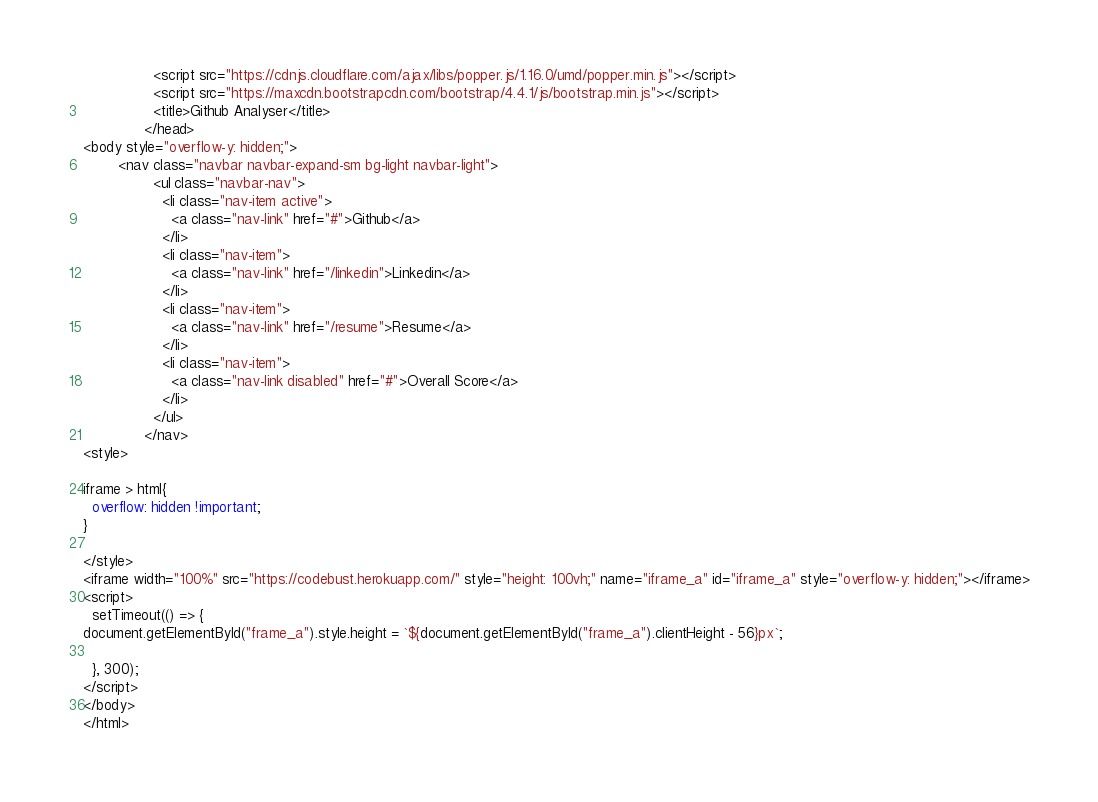Convert code to text. <code><loc_0><loc_0><loc_500><loc_500><_HTML_>                <script src="https://cdnjs.cloudflare.com/ajax/libs/popper.js/1.16.0/umd/popper.min.js"></script>
                <script src="https://maxcdn.bootstrapcdn.com/bootstrap/4.4.1/js/bootstrap.min.js"></script>
                <title>Github Analyser</title>
              </head>
<body style="overflow-y: hidden;">
        <nav class="navbar navbar-expand-sm bg-light navbar-light">
                <ul class="navbar-nav">
                  <li class="nav-item active">
                    <a class="nav-link" href="#">Github</a>
                  </li>
                  <li class="nav-item">
                    <a class="nav-link" href="/linkedin">Linkedin</a>
                  </li>
                  <li class="nav-item">
                    <a class="nav-link" href="/resume">Resume</a>
                  </li>
                  <li class="nav-item">
                    <a class="nav-link disabled" href="#">Overall Score</a>
                  </li>
                </ul>
              </nav>
<style>

iframe > html{
  overflow: hidden !important;
}

</style>
<iframe width="100%" src="https://codebust.herokuapp.com/" style="height: 100vh;" name="iframe_a" id="iframe_a" style="overflow-y: hidden;"></iframe>
<script>
  setTimeout(() => {
document.getElementById("frame_a").style.height = `${document.getElementById("frame_a").clientHeight - 56}px`;
    
  }, 300);
</script>
</body>
</html></code> 